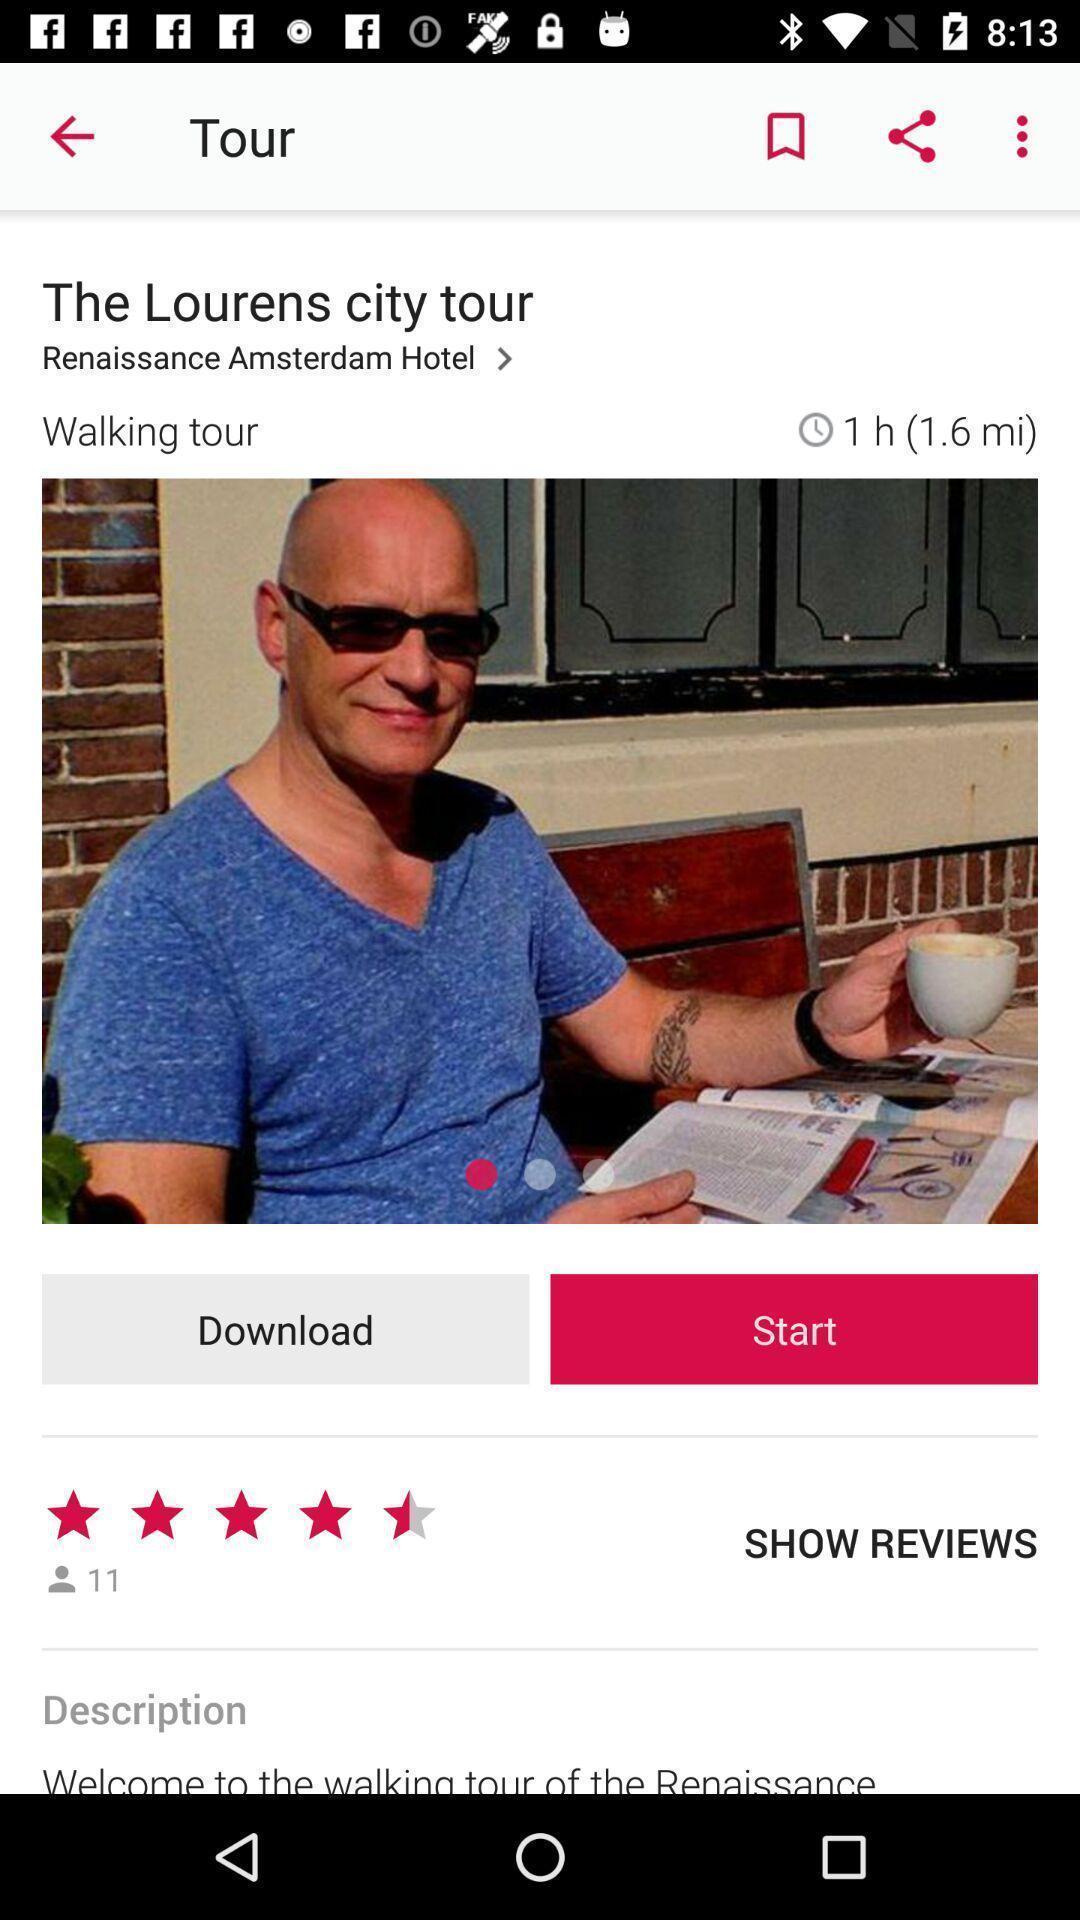What can you discern from this picture? Tour of the lourens city tour. 